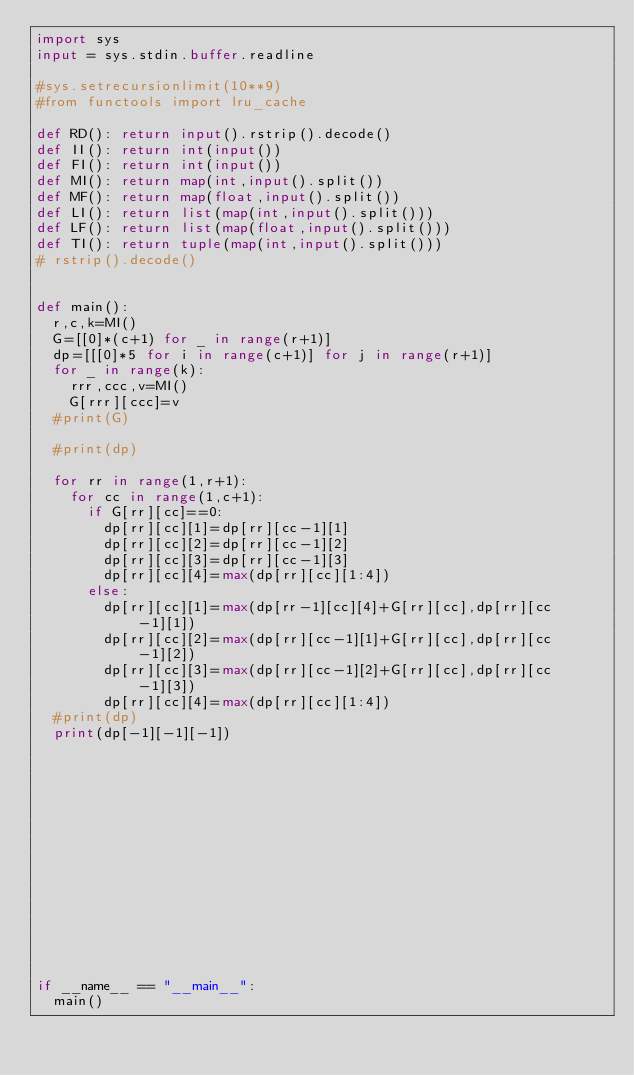Convert code to text. <code><loc_0><loc_0><loc_500><loc_500><_Python_>import sys
input = sys.stdin.buffer.readline

#sys.setrecursionlimit(10**9)
#from functools import lru_cache

def RD(): return input().rstrip().decode()
def II(): return int(input())
def FI(): return int(input())
def MI(): return map(int,input().split())
def MF(): return map(float,input().split())
def LI(): return list(map(int,input().split()))
def LF(): return list(map(float,input().split()))
def TI(): return tuple(map(int,input().split()))
# rstrip().decode()


def main():
	r,c,k=MI()
	G=[[0]*(c+1) for _ in range(r+1)]
	dp=[[[0]*5 for i in range(c+1)] for j in range(r+1)]
	for _ in range(k):
		rrr,ccc,v=MI()
		G[rrr][ccc]=v
	#print(G)

	#print(dp)

	for rr in range(1,r+1):
		for cc in range(1,c+1):
			if G[rr][cc]==0:
				dp[rr][cc][1]=dp[rr][cc-1][1]
				dp[rr][cc][2]=dp[rr][cc-1][2]
				dp[rr][cc][3]=dp[rr][cc-1][3]
				dp[rr][cc][4]=max(dp[rr][cc][1:4])
			else:
				dp[rr][cc][1]=max(dp[rr-1][cc][4]+G[rr][cc],dp[rr][cc-1][1])
				dp[rr][cc][2]=max(dp[rr][cc-1][1]+G[rr][cc],dp[rr][cc-1][2])
				dp[rr][cc][3]=max(dp[rr][cc-1][2]+G[rr][cc],dp[rr][cc-1][3])
				dp[rr][cc][4]=max(dp[rr][cc][1:4])
	#print(dp)
	print(dp[-1][-1][-1])















if __name__ == "__main__":
	main()
</code> 